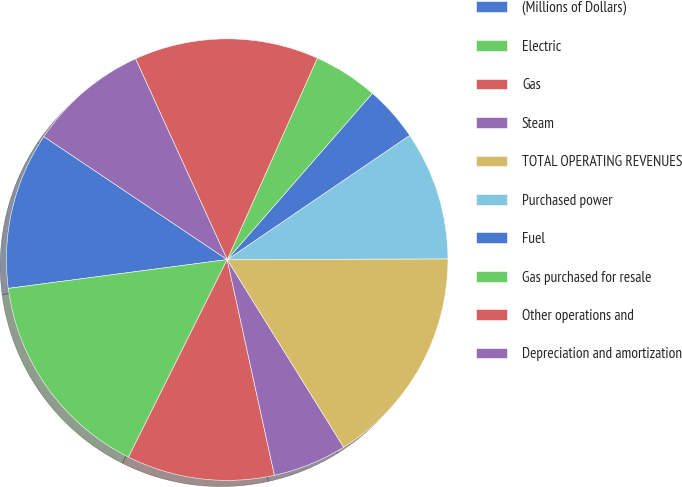Convert chart to OTSL. <chart><loc_0><loc_0><loc_500><loc_500><pie_chart><fcel>(Millions of Dollars)<fcel>Electric<fcel>Gas<fcel>Steam<fcel>TOTAL OPERATING REVENUES<fcel>Purchased power<fcel>Fuel<fcel>Gas purchased for resale<fcel>Other operations and<fcel>Depreciation and amortization<nl><fcel>11.49%<fcel>15.54%<fcel>10.81%<fcel>5.41%<fcel>16.21%<fcel>9.46%<fcel>4.06%<fcel>4.73%<fcel>13.51%<fcel>8.78%<nl></chart> 